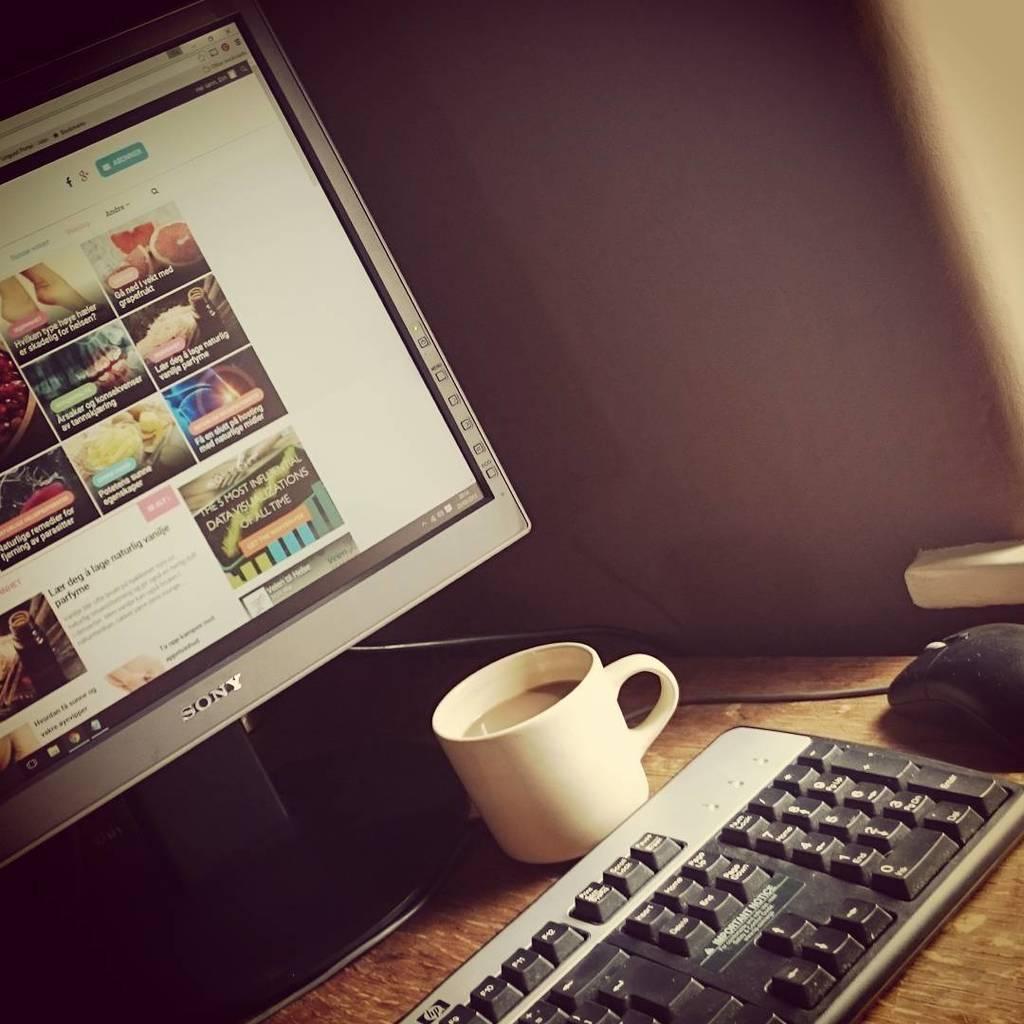Could you give a brief overview of what you see in this image? In this image I can see a monitor, a cup, a keyboard and a mouse on this table. 